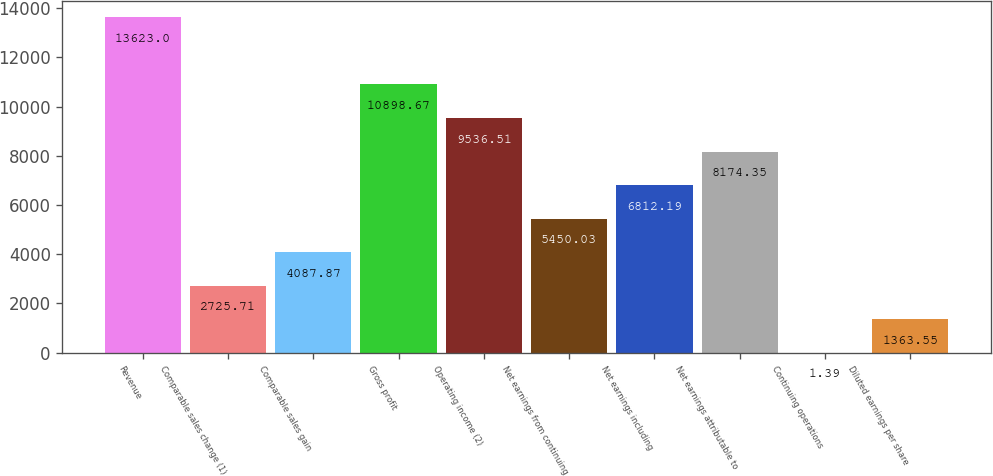Convert chart to OTSL. <chart><loc_0><loc_0><loc_500><loc_500><bar_chart><fcel>Revenue<fcel>Comparable sales change (1)<fcel>Comparable sales gain<fcel>Gross profit<fcel>Operating income (2)<fcel>Net earnings from continuing<fcel>Net earnings including<fcel>Net earnings attributable to<fcel>Continuing operations<fcel>Diluted earnings per share<nl><fcel>13623<fcel>2725.71<fcel>4087.87<fcel>10898.7<fcel>9536.51<fcel>5450.03<fcel>6812.19<fcel>8174.35<fcel>1.39<fcel>1363.55<nl></chart> 